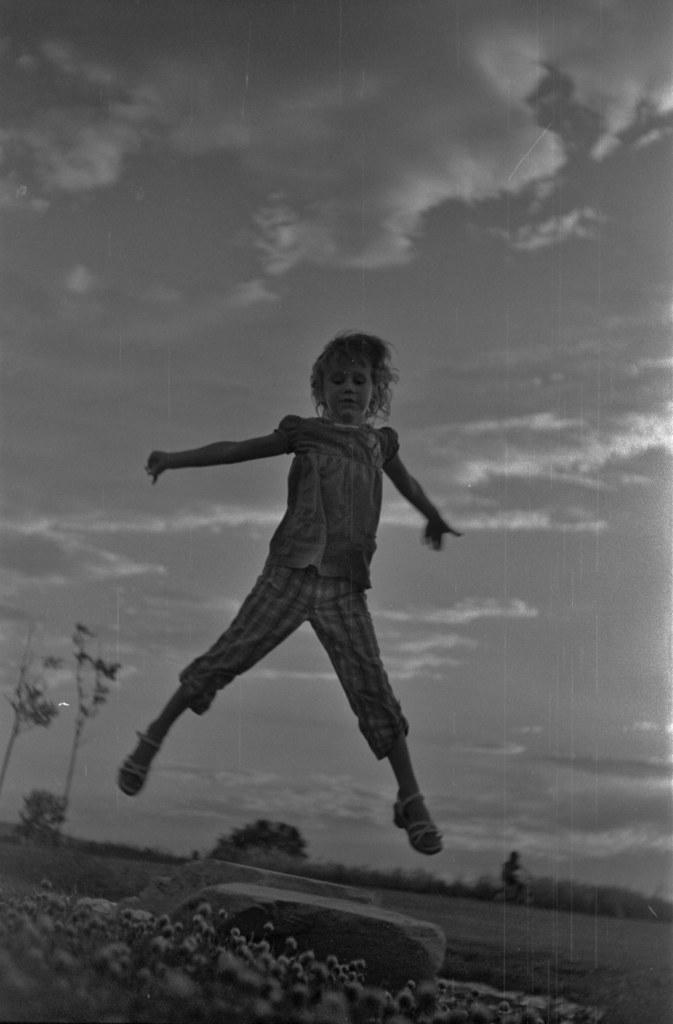Who or what is the main subject in the image? There is a person in the image. What is the person doing in the image? The person is jumping. What type of natural elements can be seen in the image? There are plants and clouds in the image. What is the color scheme of the image? The image is black and white. How many visitors can be seen on the edge of the image? There are no visitors present in the image, and the concept of an "edge" is not applicable to a black and white image. 